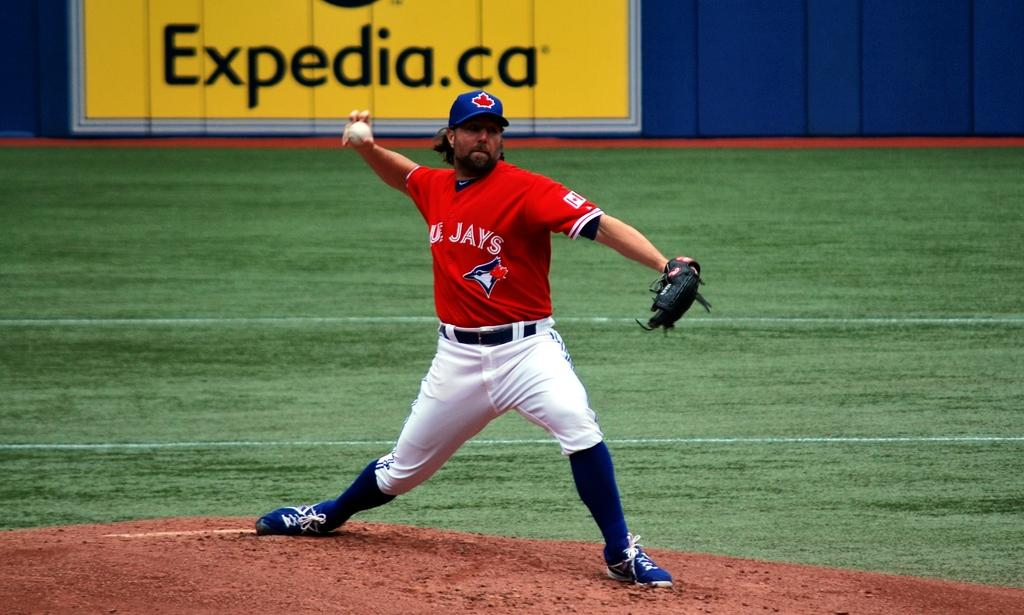<image>
Give a short and clear explanation of the subsequent image. A Blue Jay player winding up to throw a pitch. 